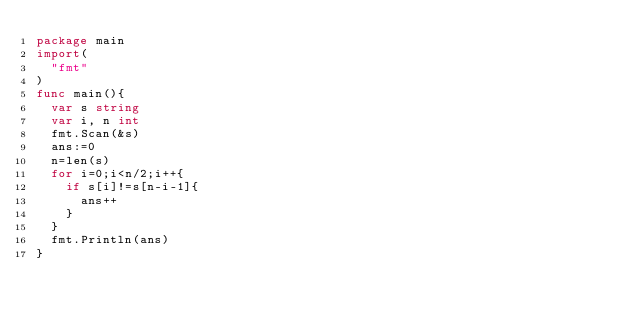<code> <loc_0><loc_0><loc_500><loc_500><_Go_>package main
import(
  "fmt"
)
func main(){
  var s string
  var i, n int
  fmt.Scan(&s)
  ans:=0
  n=len(s)
  for i=0;i<n/2;i++{
    if s[i]!=s[n-i-1]{
      ans++
    }
  }
  fmt.Println(ans)
}
</code> 